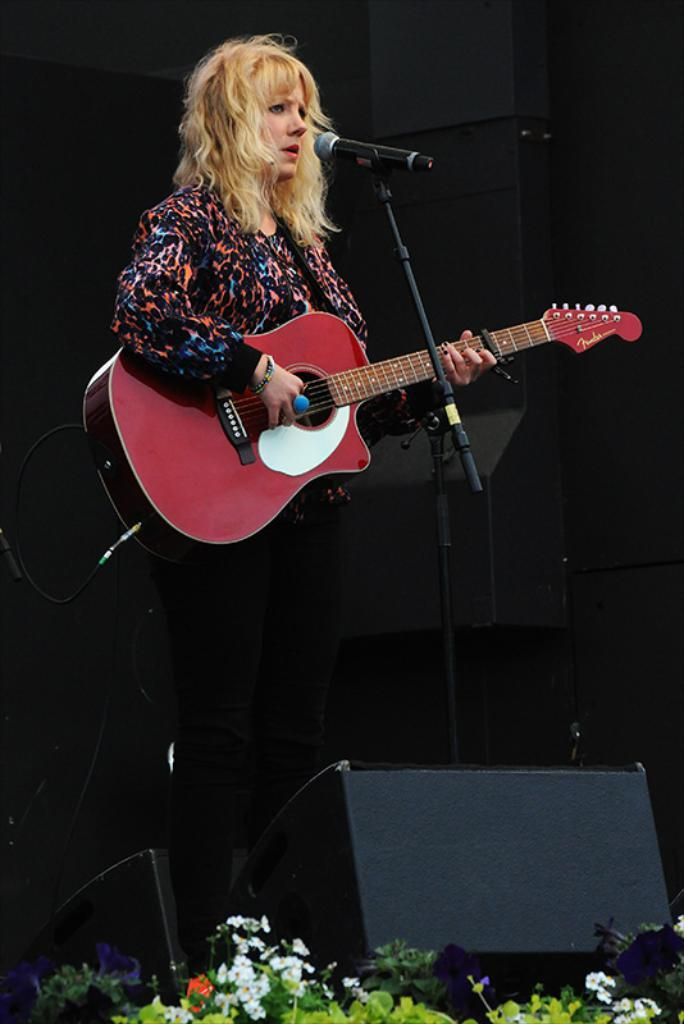Who is the main subject in the image? There is a woman in the image. What is the woman doing in the image? The woman is standing and holding a guitar. What object is in front of the woman? There is a microphone in front of the woman. What type of vegetation can be seen in the image? There are plants visible in the image. What arithmetic problem is the woman solving in the image? There is no arithmetic problem visible in the image. Is there a chair present in the image? No, there is no chair present in the image. 